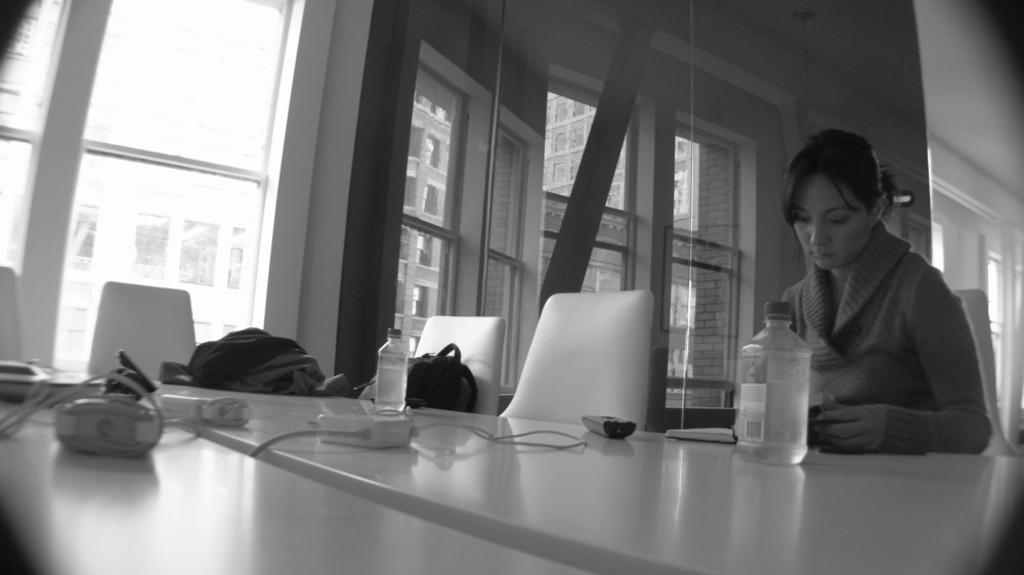How would you summarize this image in a sentence or two? In this picture there is a table on which some equipment, water bottle, remotes and bags were placed. In front of a table there is a woman sitting in the chair. There are some empty chairs. In the background, there is a window and a wall here. 